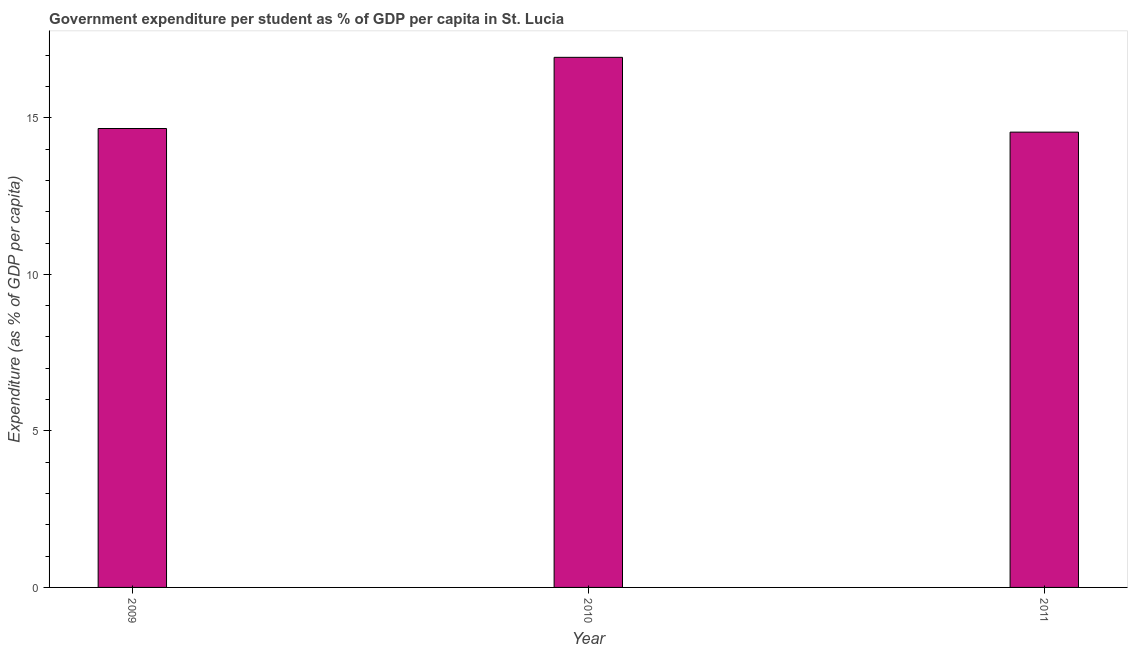Does the graph contain grids?
Your answer should be compact. No. What is the title of the graph?
Keep it short and to the point. Government expenditure per student as % of GDP per capita in St. Lucia. What is the label or title of the Y-axis?
Offer a terse response. Expenditure (as % of GDP per capita). What is the government expenditure per student in 2009?
Make the answer very short. 14.66. Across all years, what is the maximum government expenditure per student?
Provide a short and direct response. 16.93. Across all years, what is the minimum government expenditure per student?
Make the answer very short. 14.54. In which year was the government expenditure per student maximum?
Your answer should be compact. 2010. What is the sum of the government expenditure per student?
Your answer should be very brief. 46.13. What is the difference between the government expenditure per student in 2009 and 2011?
Provide a short and direct response. 0.12. What is the average government expenditure per student per year?
Provide a short and direct response. 15.38. What is the median government expenditure per student?
Your answer should be compact. 14.66. In how many years, is the government expenditure per student greater than 16 %?
Offer a terse response. 1. Do a majority of the years between 2011 and 2010 (inclusive) have government expenditure per student greater than 14 %?
Give a very brief answer. No. What is the ratio of the government expenditure per student in 2009 to that in 2010?
Your answer should be compact. 0.87. Is the government expenditure per student in 2009 less than that in 2011?
Offer a very short reply. No. What is the difference between the highest and the second highest government expenditure per student?
Your response must be concise. 2.27. What is the difference between the highest and the lowest government expenditure per student?
Ensure brevity in your answer.  2.39. How many bars are there?
Ensure brevity in your answer.  3. How many years are there in the graph?
Offer a very short reply. 3. What is the difference between two consecutive major ticks on the Y-axis?
Keep it short and to the point. 5. What is the Expenditure (as % of GDP per capita) in 2009?
Offer a terse response. 14.66. What is the Expenditure (as % of GDP per capita) of 2010?
Provide a succinct answer. 16.93. What is the Expenditure (as % of GDP per capita) of 2011?
Ensure brevity in your answer.  14.54. What is the difference between the Expenditure (as % of GDP per capita) in 2009 and 2010?
Offer a terse response. -2.27. What is the difference between the Expenditure (as % of GDP per capita) in 2009 and 2011?
Your answer should be very brief. 0.12. What is the difference between the Expenditure (as % of GDP per capita) in 2010 and 2011?
Ensure brevity in your answer.  2.39. What is the ratio of the Expenditure (as % of GDP per capita) in 2009 to that in 2010?
Offer a terse response. 0.87. What is the ratio of the Expenditure (as % of GDP per capita) in 2010 to that in 2011?
Give a very brief answer. 1.16. 